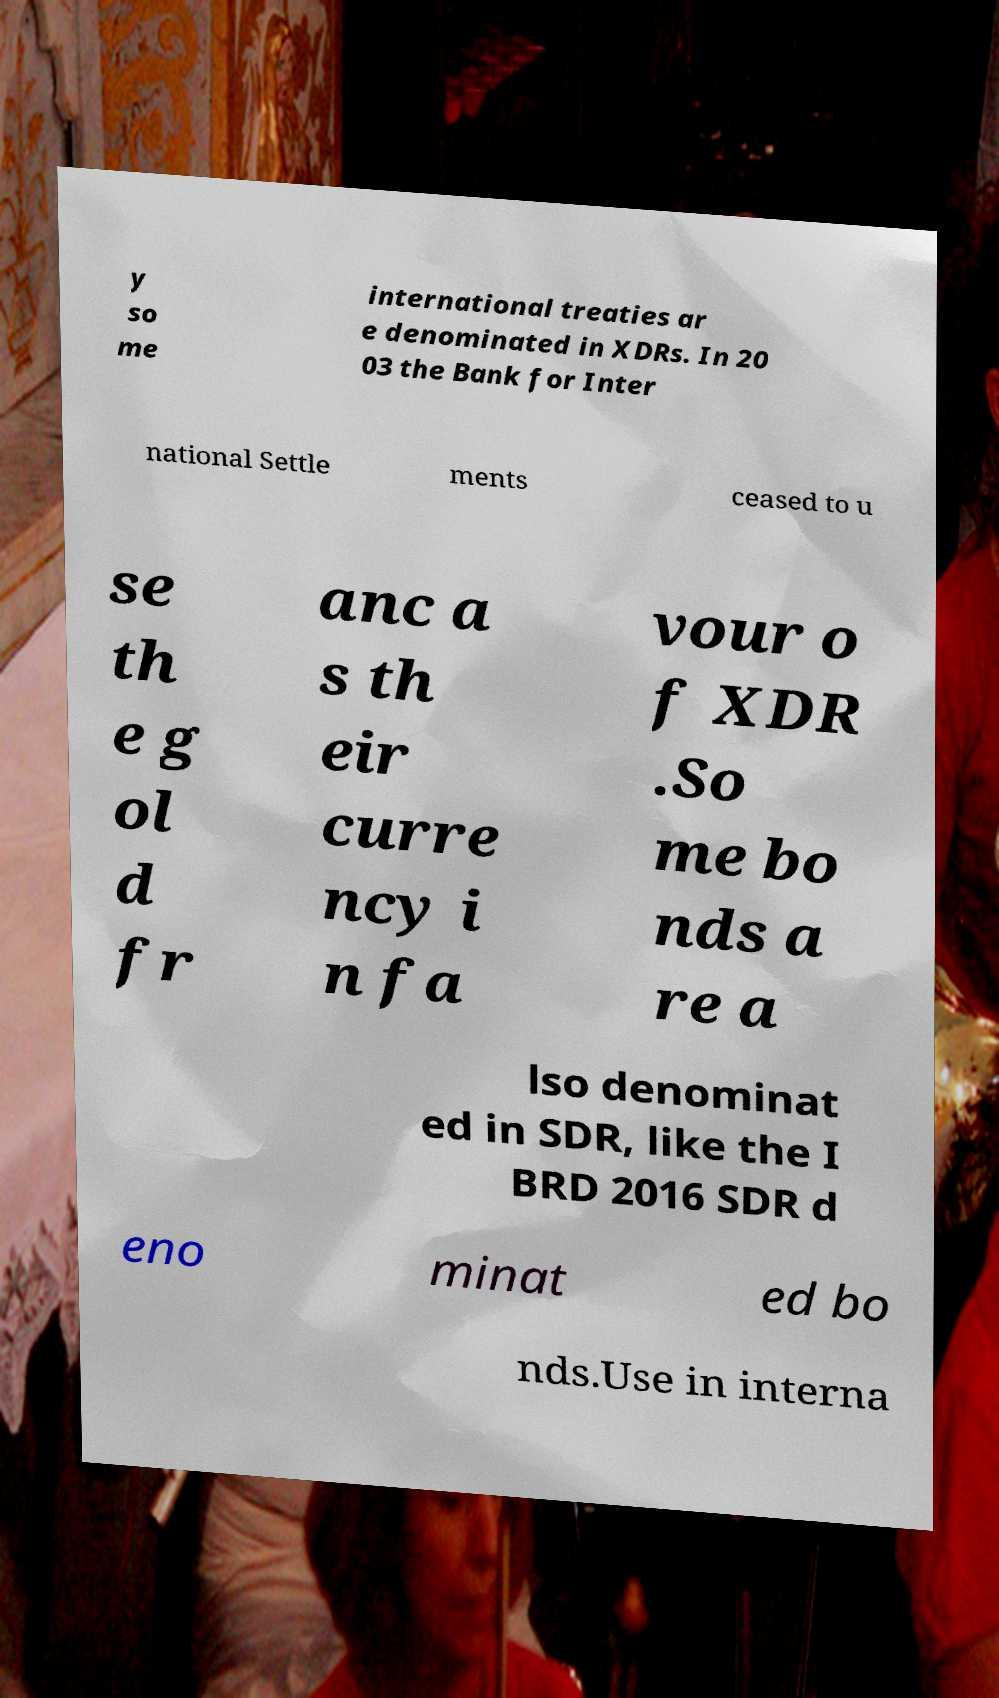Can you accurately transcribe the text from the provided image for me? y so me international treaties ar e denominated in XDRs. In 20 03 the Bank for Inter national Settle ments ceased to u se th e g ol d fr anc a s th eir curre ncy i n fa vour o f XDR .So me bo nds a re a lso denominat ed in SDR, like the I BRD 2016 SDR d eno minat ed bo nds.Use in interna 